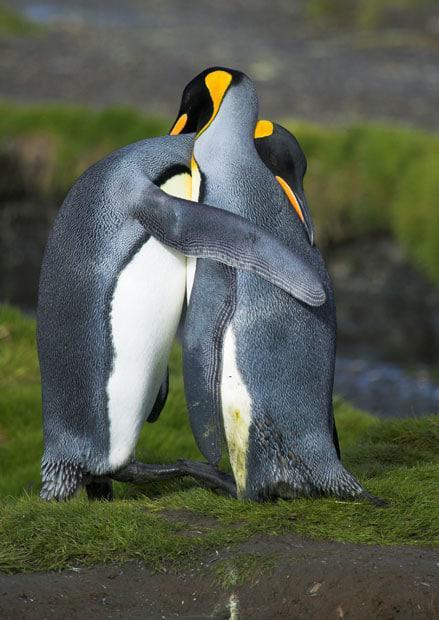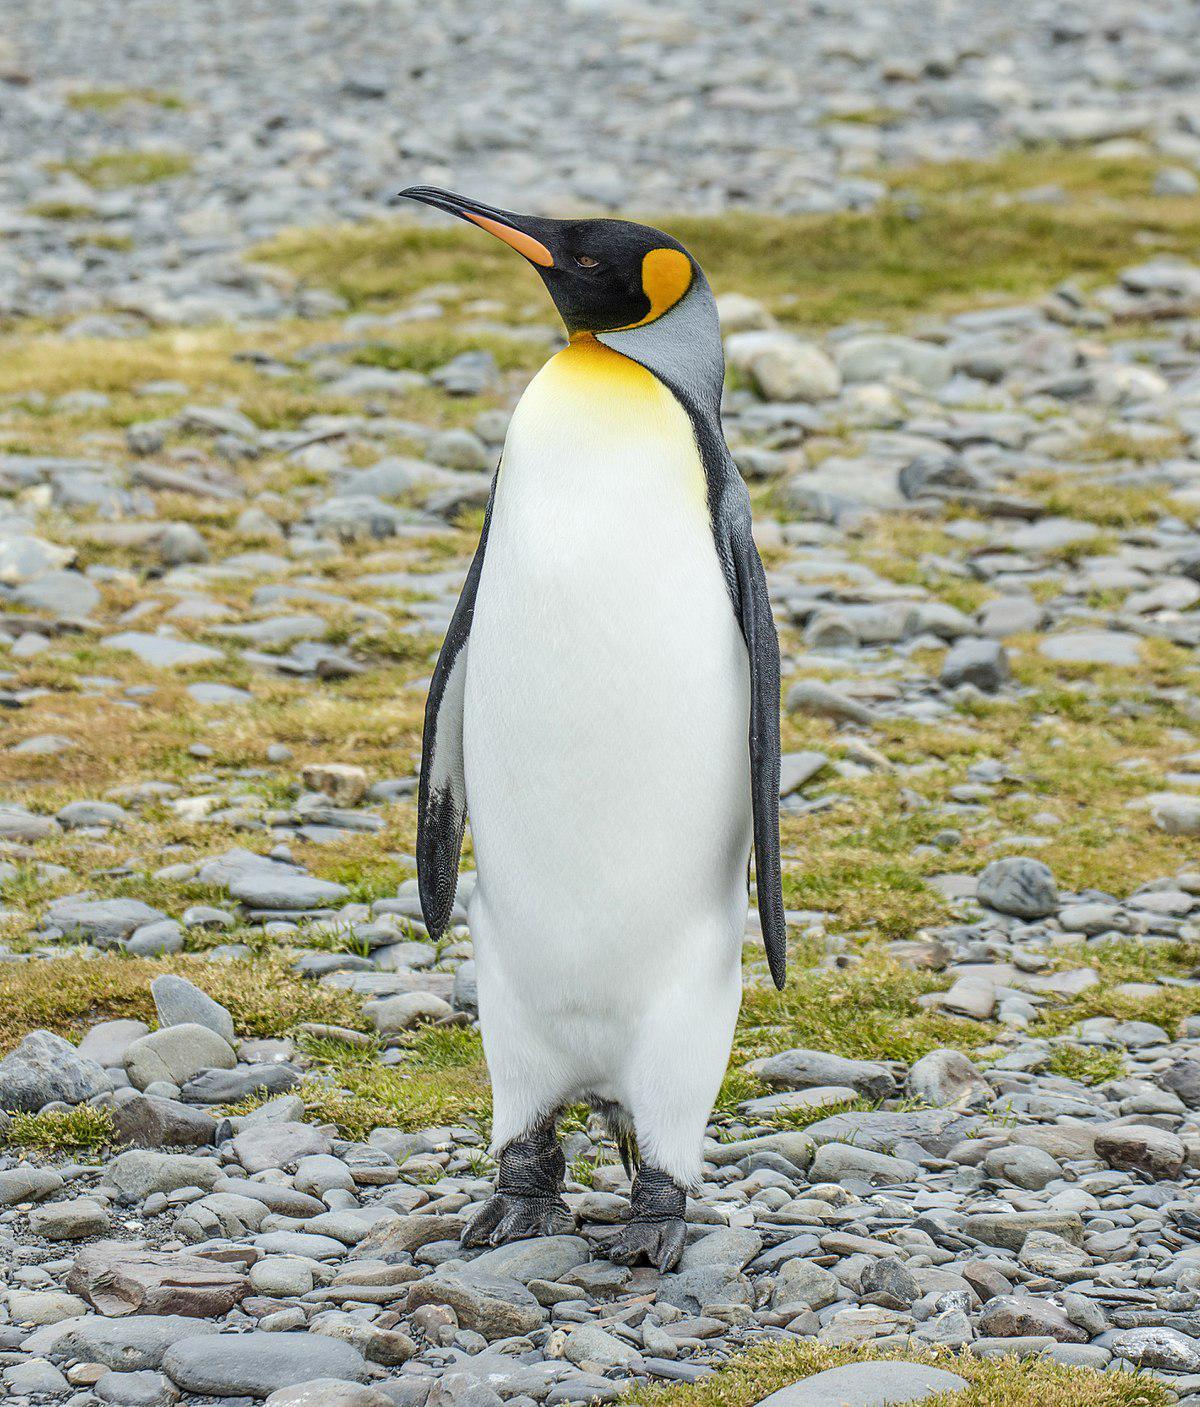The first image is the image on the left, the second image is the image on the right. Evaluate the accuracy of this statement regarding the images: "At least one image contains at least five penguins.". Is it true? Answer yes or no. No. 